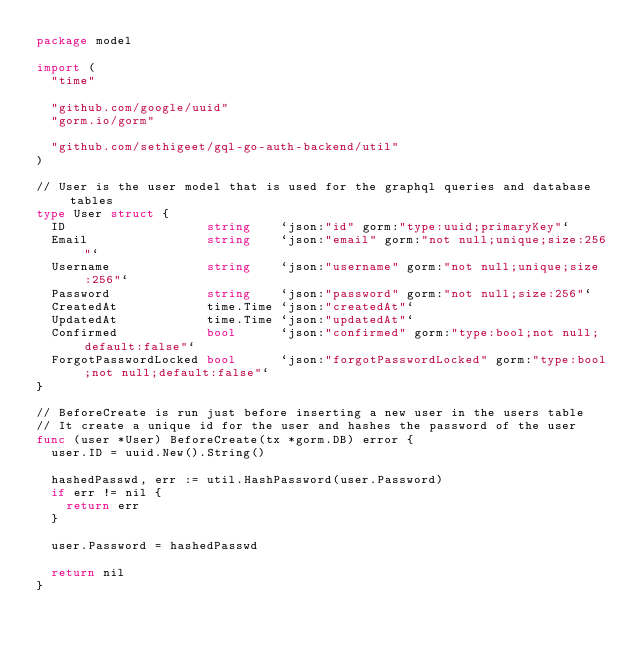<code> <loc_0><loc_0><loc_500><loc_500><_Go_>package model

import (
	"time"

	"github.com/google/uuid"
	"gorm.io/gorm"

	"github.com/sethigeet/gql-go-auth-backend/util"
)

// User is the user model that is used for the graphql queries and database tables
type User struct {
	ID                   string    `json:"id" gorm:"type:uuid;primaryKey"`
	Email                string    `json:"email" gorm:"not null;unique;size:256"`
	Username             string    `json:"username" gorm:"not null;unique;size:256"`
	Password             string    `json:"password" gorm:"not null;size:256"`
	CreatedAt            time.Time `json:"createdAt"`
	UpdatedAt            time.Time `json:"updatedAt"`
	Confirmed            bool      `json:"confirmed" gorm:"type:bool;not null;default:false"`
	ForgotPasswordLocked bool      `json:"forgotPasswordLocked" gorm:"type:bool;not null;default:false"`
}

// BeforeCreate is run just before inserting a new user in the users table
// It create a unique id for the user and hashes the password of the user
func (user *User) BeforeCreate(tx *gorm.DB) error {
	user.ID = uuid.New().String()

	hashedPasswd, err := util.HashPassword(user.Password)
	if err != nil {
		return err
	}

	user.Password = hashedPasswd

	return nil
}
</code> 